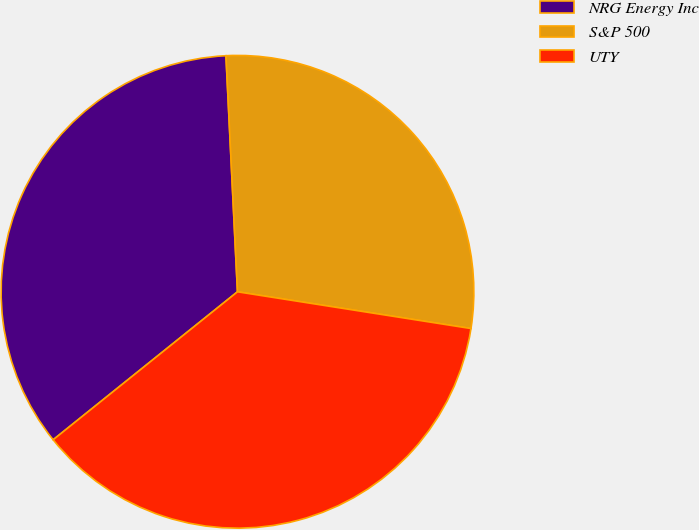Convert chart to OTSL. <chart><loc_0><loc_0><loc_500><loc_500><pie_chart><fcel>NRG Energy Inc<fcel>S&P 500<fcel>UTY<nl><fcel>34.99%<fcel>28.26%<fcel>36.75%<nl></chart> 